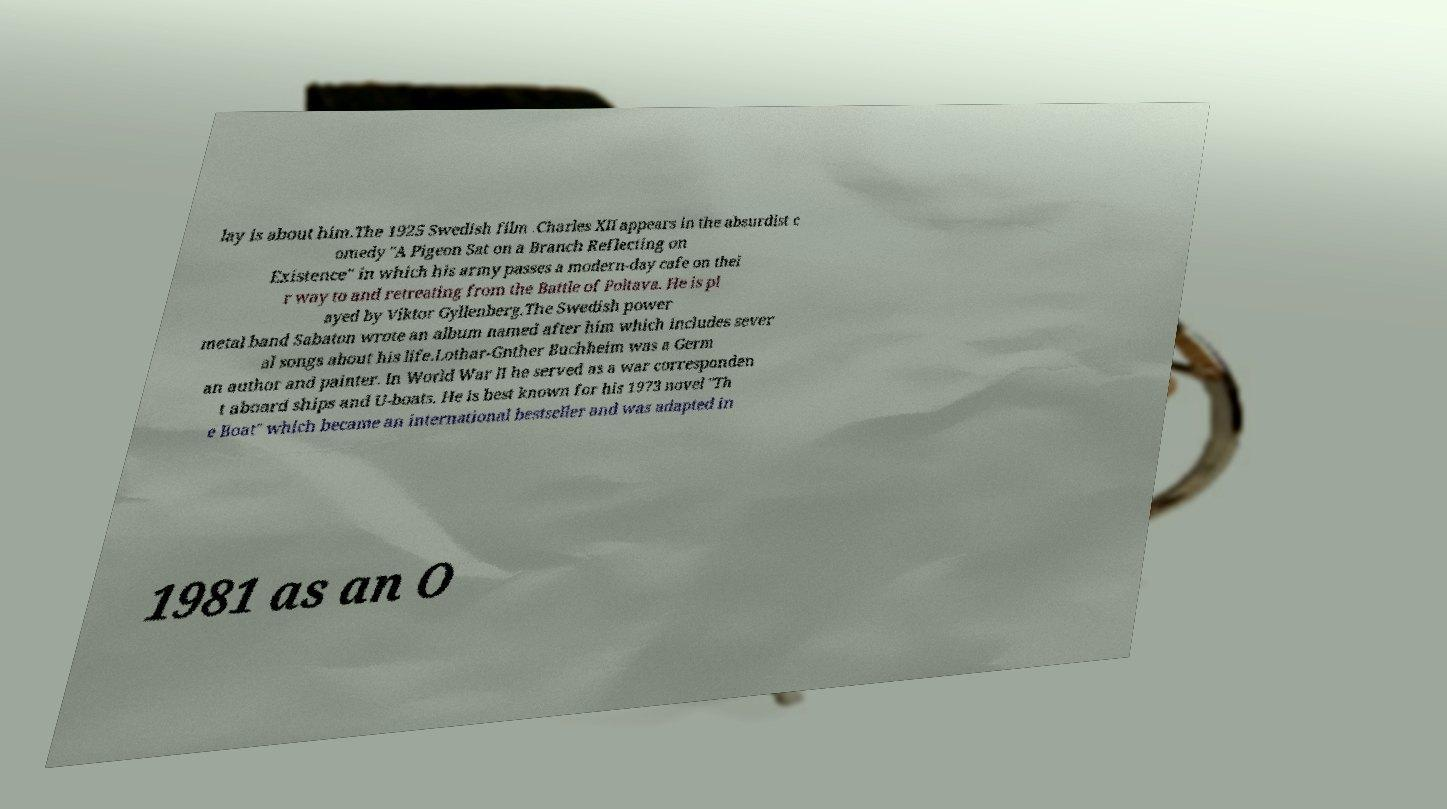There's text embedded in this image that I need extracted. Can you transcribe it verbatim? lay is about him.The 1925 Swedish film .Charles XII appears in the absurdist c omedy "A Pigeon Sat on a Branch Reflecting on Existence" in which his army passes a modern-day cafe on thei r way to and retreating from the Battle of Poltava. He is pl ayed by Viktor Gyllenberg.The Swedish power metal band Sabaton wrote an album named after him which includes sever al songs about his life.Lothar-Gnther Buchheim was a Germ an author and painter. In World War II he served as a war corresponden t aboard ships and U-boats. He is best known for his 1973 novel "Th e Boat" which became an international bestseller and was adapted in 1981 as an O 